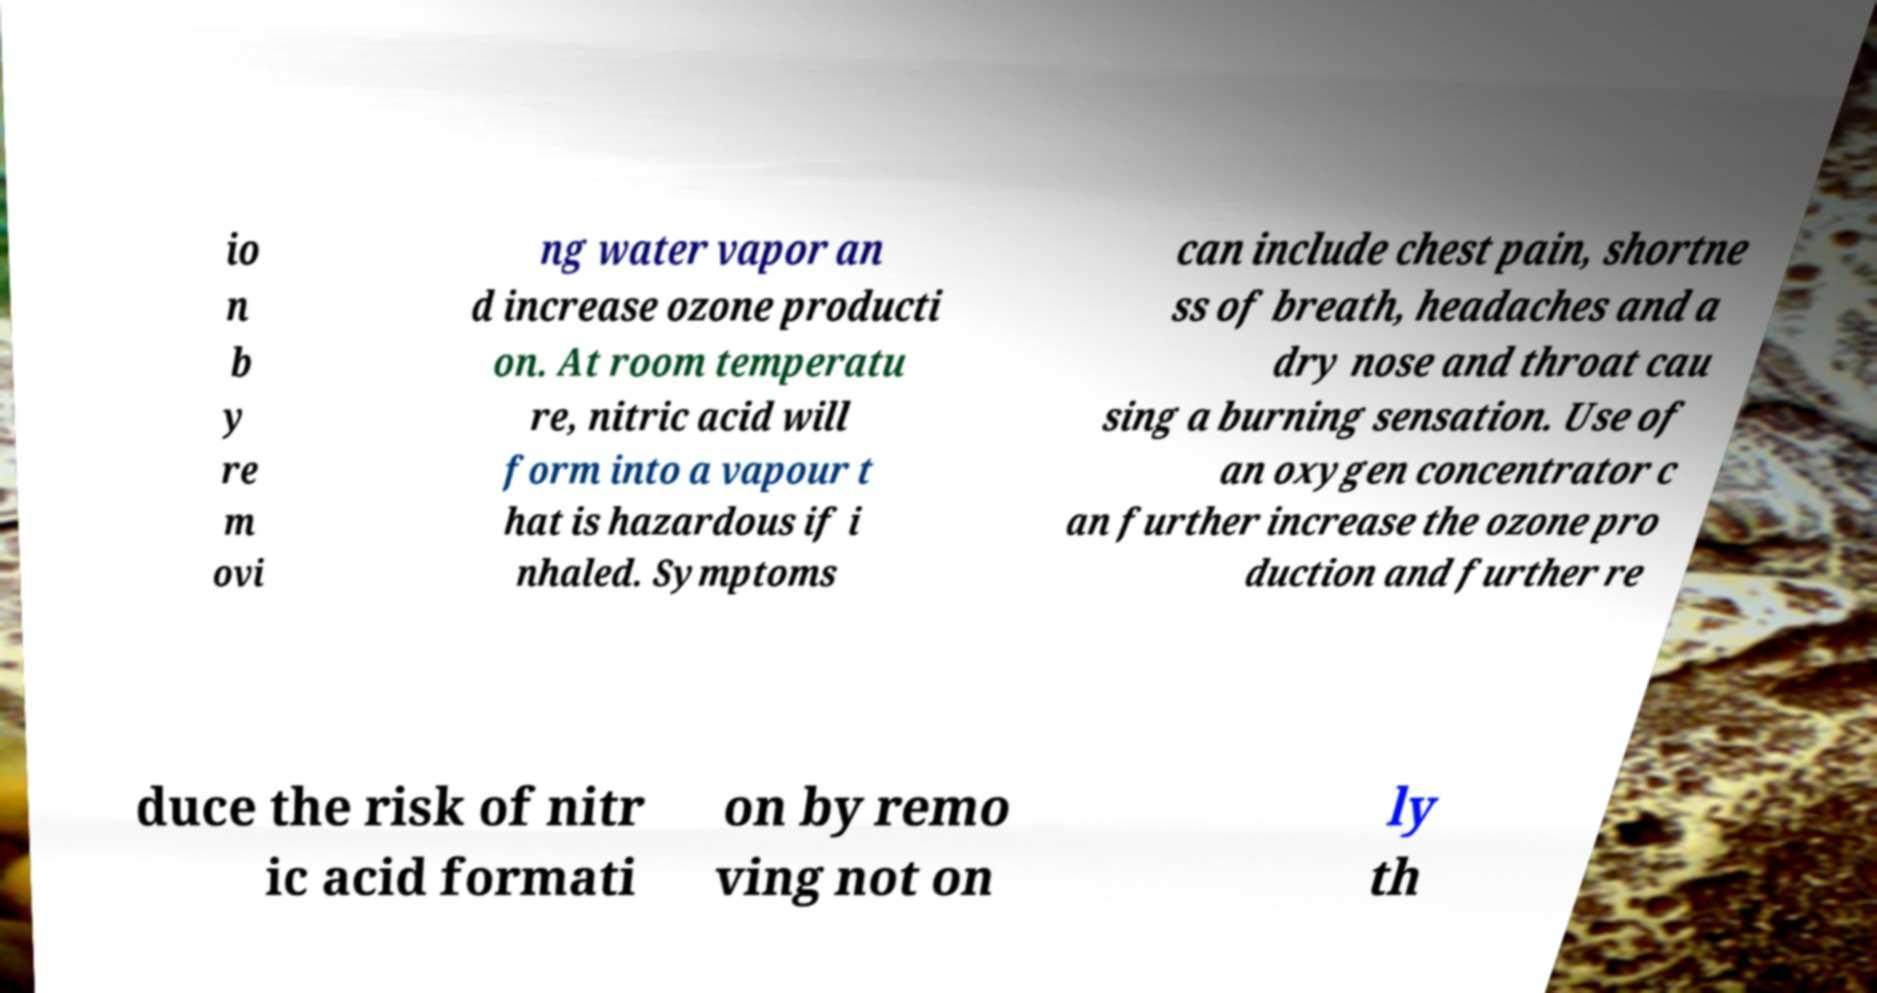There's text embedded in this image that I need extracted. Can you transcribe it verbatim? io n b y re m ovi ng water vapor an d increase ozone producti on. At room temperatu re, nitric acid will form into a vapour t hat is hazardous if i nhaled. Symptoms can include chest pain, shortne ss of breath, headaches and a dry nose and throat cau sing a burning sensation. Use of an oxygen concentrator c an further increase the ozone pro duction and further re duce the risk of nitr ic acid formati on by remo ving not on ly th 